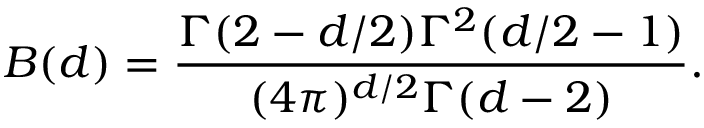Convert formula to latex. <formula><loc_0><loc_0><loc_500><loc_500>B ( d ) = \frac { \Gamma ( 2 - d / 2 ) \Gamma ^ { 2 } ( d / 2 - 1 ) } { ( 4 \pi ) ^ { d / 2 } \Gamma ( d - 2 ) } .</formula> 